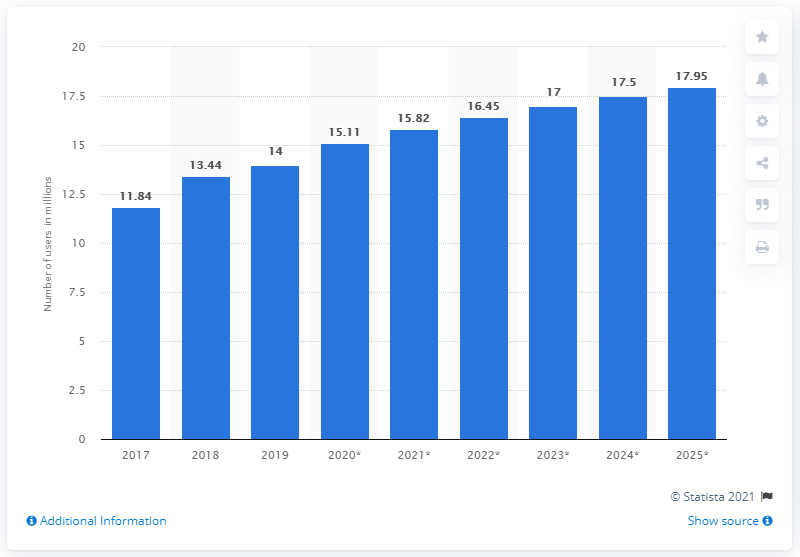Identify some key points in this picture. By the end of 2021, Facebook is projected to gain approximately 0.71 million new users in Saudi Arabia, an increase from the previous year. By 2025, it is projected that there will be approximately 17.95 million Facebook users in Saudi Arabia. According to projections, the year 2025 will see the highest number of users accessing Facebook in Saudi Arabia. In 2019, the number of Facebook users in Saudi Arabia was 14 million. 